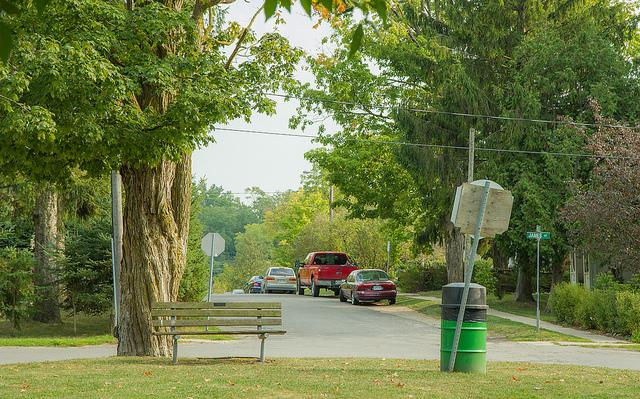What does the plaque on the back of this bench say? sit down 